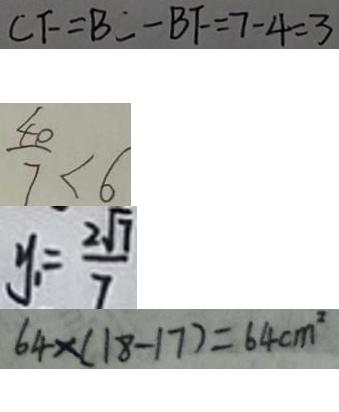<formula> <loc_0><loc_0><loc_500><loc_500>C F = B C - B F = 7 - 4 = 3 
 \frac { 4 0 } { 7 } < 6 
 y _ { 1 } = \frac { 2 \sqrt { 7 } } { 7 } 
 6 4 \times ( 1 8 - 1 7 ) = 6 4 c m ^ { 2 }</formula> 